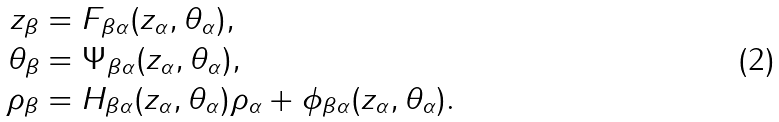Convert formula to latex. <formula><loc_0><loc_0><loc_500><loc_500>z _ { \beta } & = F _ { \beta \alpha } ( z _ { \alpha } , \theta _ { \alpha } ) , \\ \theta _ { \beta } & = \Psi _ { \beta \alpha } ( z _ { \alpha } , \theta _ { \alpha } ) , \\ \rho _ { \beta } & = H _ { \beta \alpha } ( z _ { \alpha } , \theta _ { \alpha } ) \rho _ { \alpha } + \phi _ { \beta \alpha } ( z _ { \alpha } , \theta _ { \alpha } ) .</formula> 